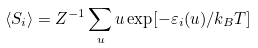<formula> <loc_0><loc_0><loc_500><loc_500>\langle { S } _ { i } \rangle = Z ^ { - 1 } \sum _ { u } { u } \exp [ - \varepsilon _ { i } ( { u } ) / k _ { B } T ]</formula> 